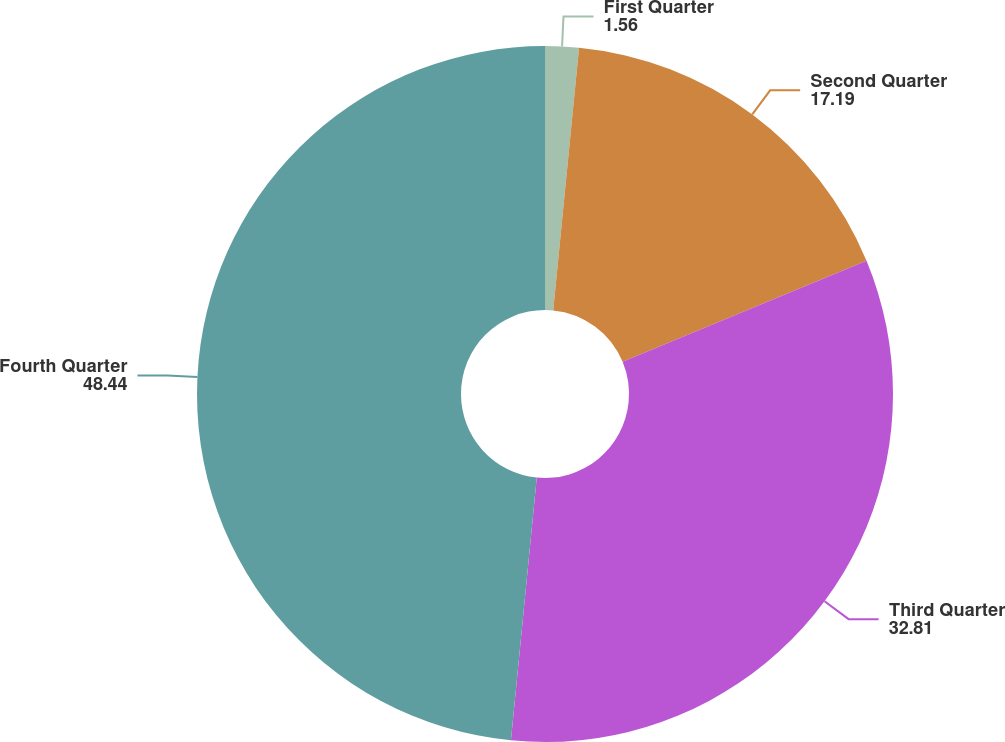Convert chart. <chart><loc_0><loc_0><loc_500><loc_500><pie_chart><fcel>First Quarter<fcel>Second Quarter<fcel>Third Quarter<fcel>Fourth Quarter<nl><fcel>1.56%<fcel>17.19%<fcel>32.81%<fcel>48.44%<nl></chart> 